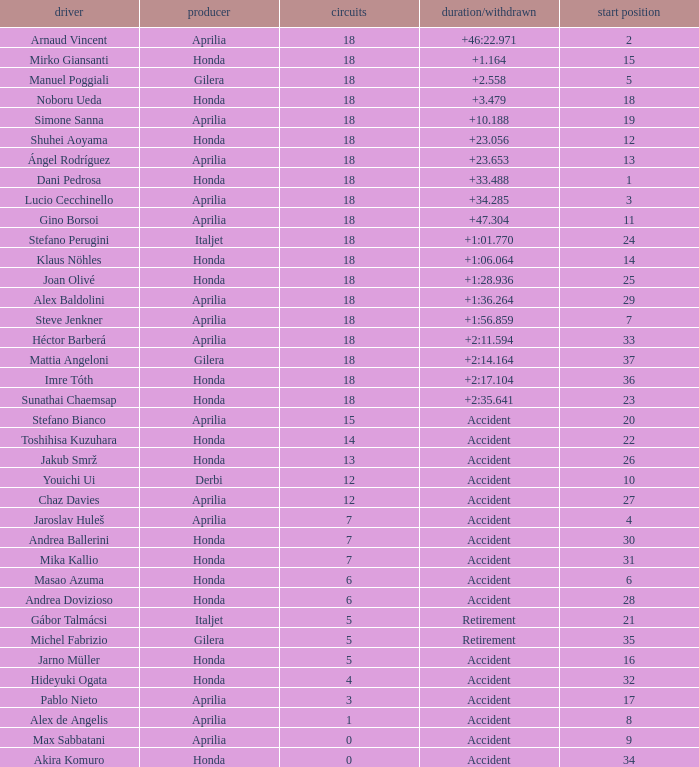What is the average number of laps with an accident time/retired, aprilia manufacturer and a grid of 27? 12.0. 